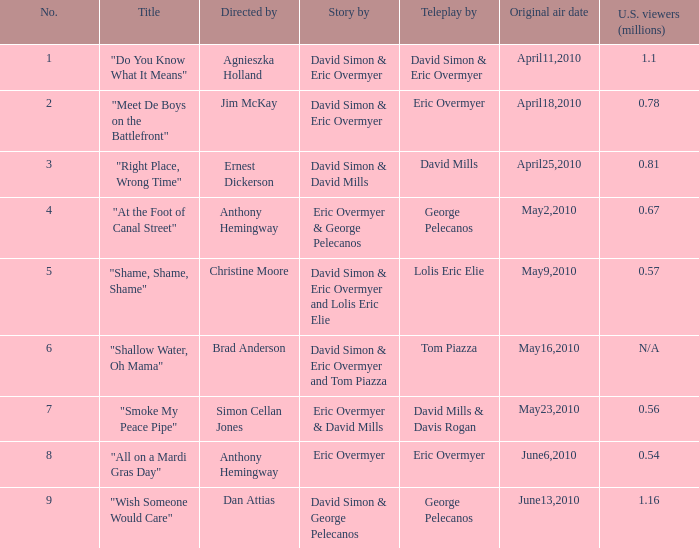Identify the highest quantity 9.0. 